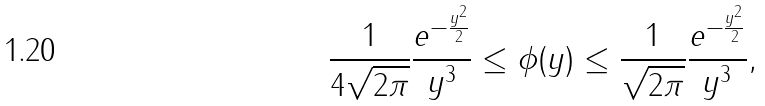<formula> <loc_0><loc_0><loc_500><loc_500>\frac { 1 } { 4 \sqrt { 2 \pi } } \frac { e ^ { - \frac { y ^ { 2 } } { 2 } } } { y ^ { 3 } } \leq \phi ( y ) \leq \frac { 1 } { \sqrt { 2 \pi } } \frac { e ^ { - \frac { y ^ { 2 } } { 2 } } } { y ^ { 3 } } , \\</formula> 